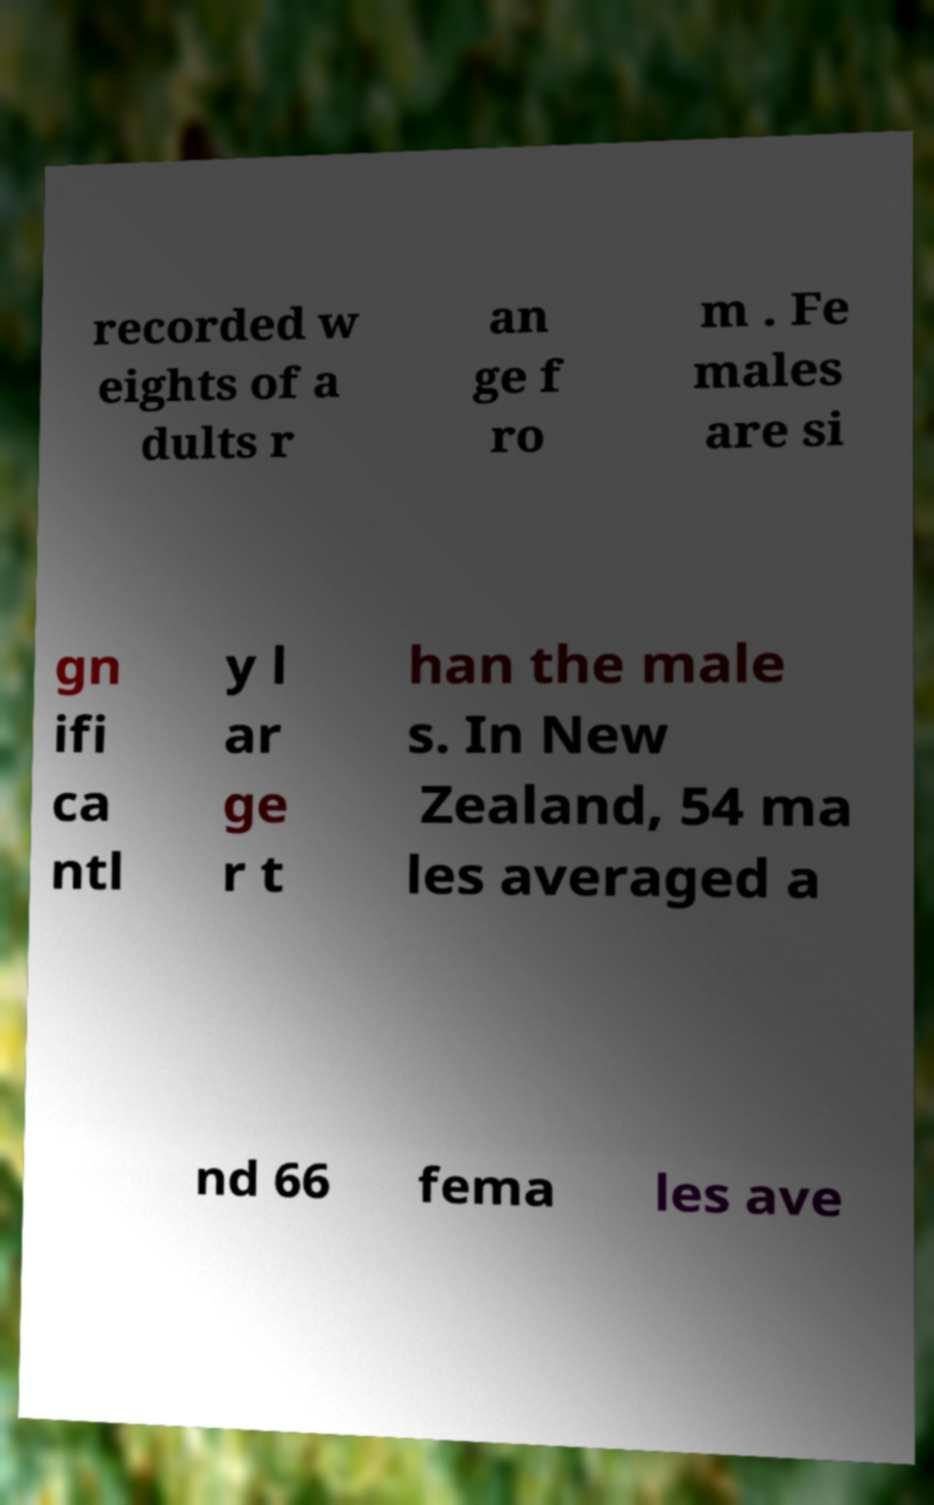There's text embedded in this image that I need extracted. Can you transcribe it verbatim? recorded w eights of a dults r an ge f ro m . Fe males are si gn ifi ca ntl y l ar ge r t han the male s. In New Zealand, 54 ma les averaged a nd 66 fema les ave 